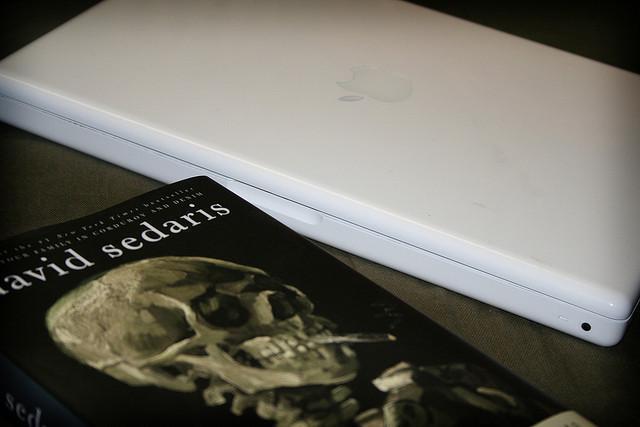How many people are in this photo?
Give a very brief answer. 0. 